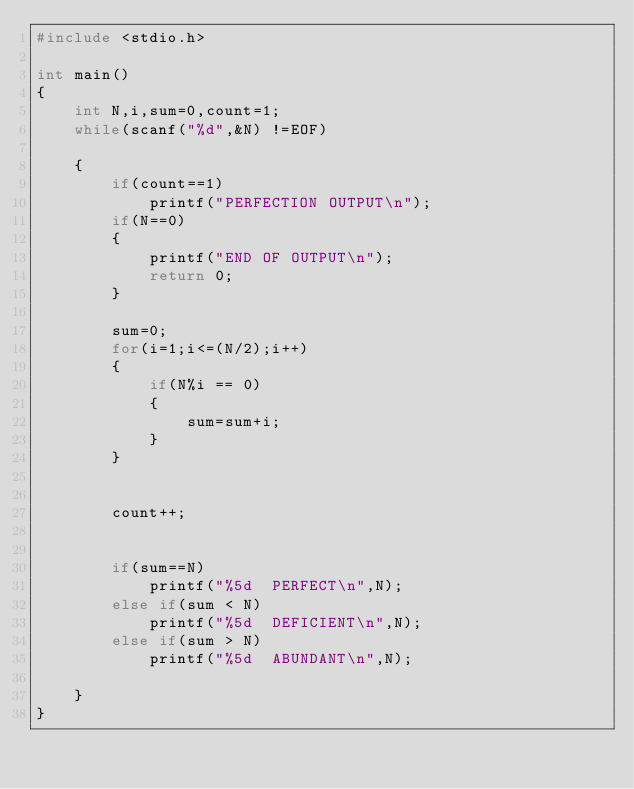<code> <loc_0><loc_0><loc_500><loc_500><_C_>#include <stdio.h>

int main()
{
    int N,i,sum=0,count=1;
    while(scanf("%d",&N) !=EOF)

    {
        if(count==1)
            printf("PERFECTION OUTPUT\n");
        if(N==0)
        {
            printf("END OF OUTPUT\n");
            return 0;
        }

        sum=0;
        for(i=1;i<=(N/2);i++)
        {
            if(N%i == 0)
            {
                sum=sum+i;
            }
        }


        count++;


        if(sum==N)
            printf("%5d  PERFECT\n",N);
        else if(sum < N)
            printf("%5d  DEFICIENT\n",N);
        else if(sum > N)
            printf("%5d  ABUNDANT\n",N);

    }
}
</code> 